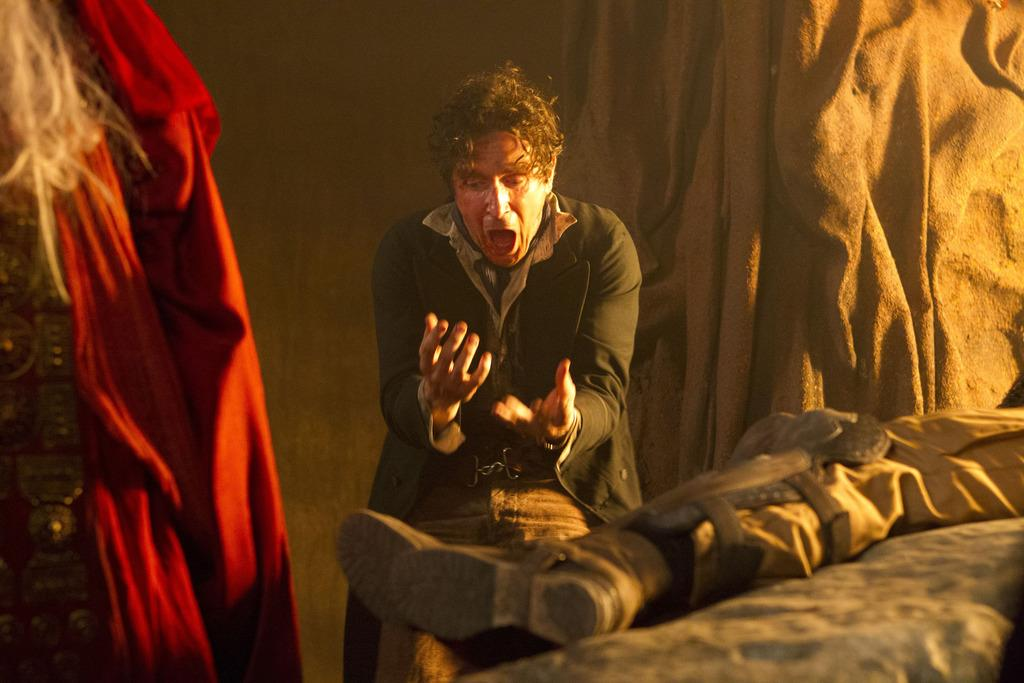What is the position of the person in the image? There is a person standing in the image, and another person lying on an object. Can you describe the clothes visible in the image? The clothes are on the left side of the image. What is the weight of the calendar in the image? There is no calendar present in the image, so it is not possible to determine its weight. 